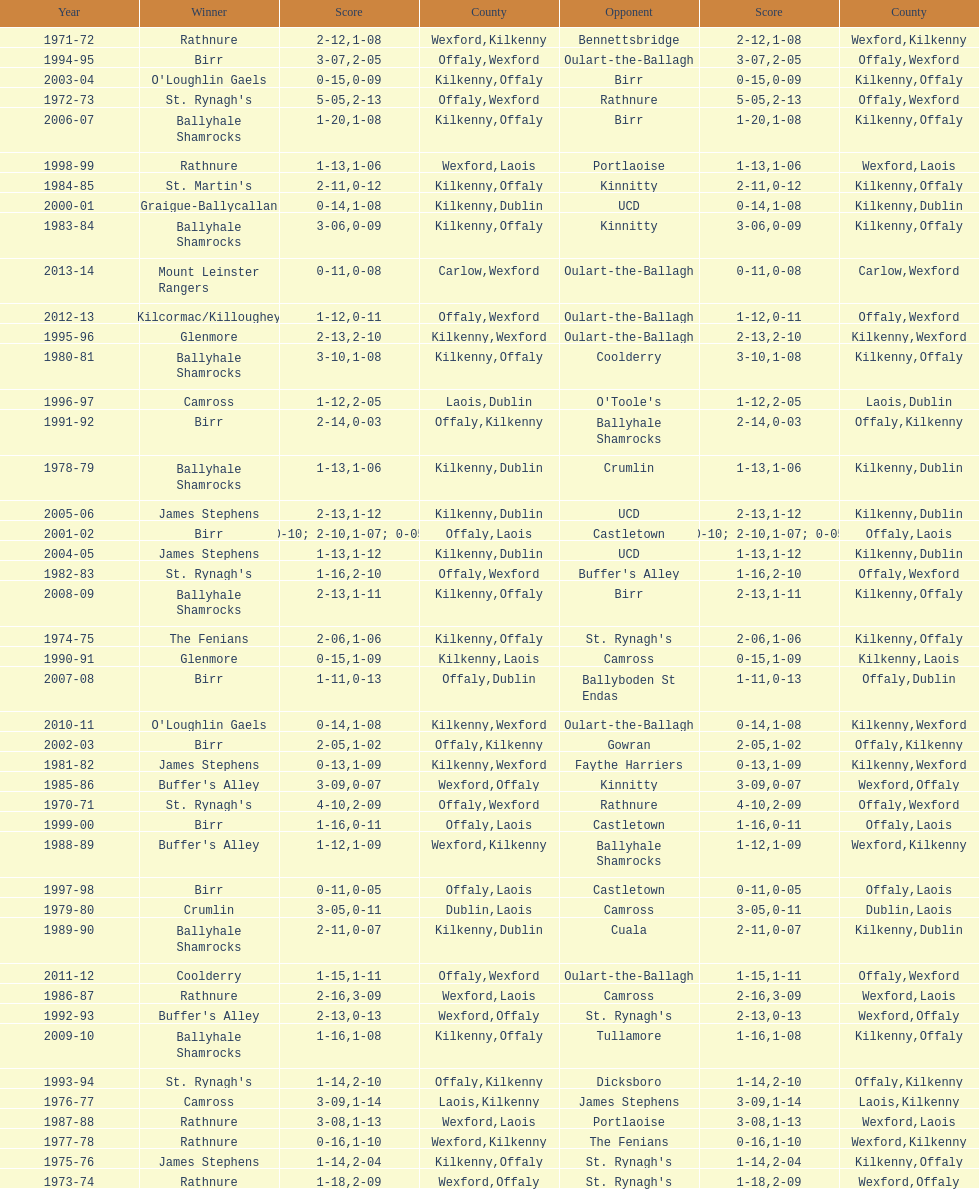How many consecutive years did rathnure win? 2. 